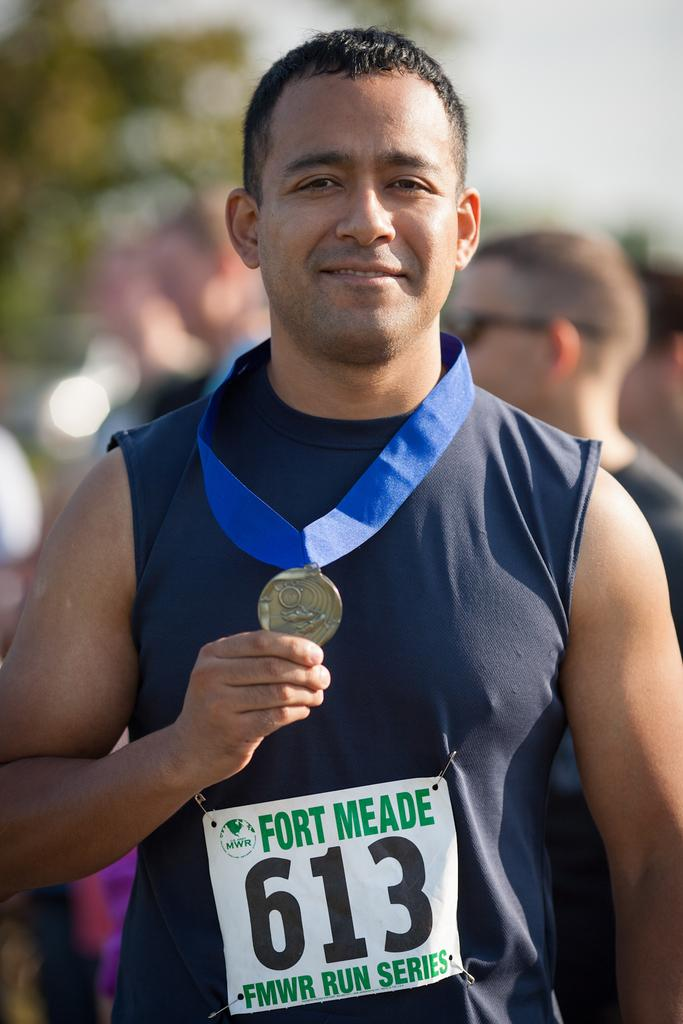<image>
Render a clear and concise summary of the photo. Runner number 613 in the Fort Meade run series poses with his medal. 